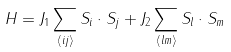Convert formula to latex. <formula><loc_0><loc_0><loc_500><loc_500>H = J _ { 1 } \sum _ { \langle i j \rangle } { S } _ { i } \cdot { S } _ { j } + J _ { 2 } \sum _ { \langle l m \rangle } { S } _ { l } \cdot { S } _ { m }</formula> 